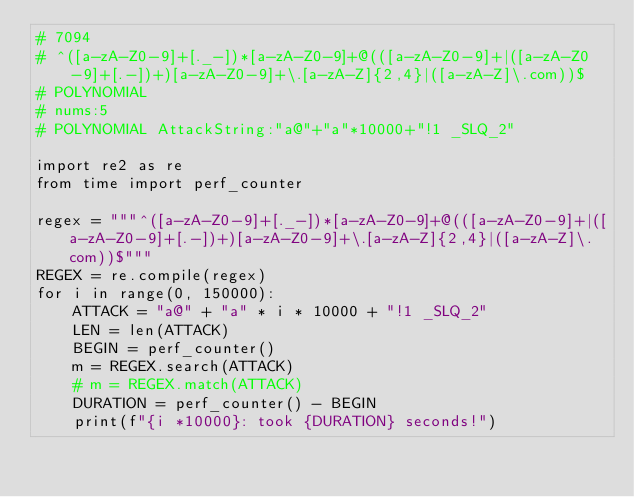<code> <loc_0><loc_0><loc_500><loc_500><_Python_># 7094
# ^([a-zA-Z0-9]+[._-])*[a-zA-Z0-9]+@(([a-zA-Z0-9]+|([a-zA-Z0-9]+[.-])+)[a-zA-Z0-9]+\.[a-zA-Z]{2,4}|([a-zA-Z]\.com))$
# POLYNOMIAL
# nums:5
# POLYNOMIAL AttackString:"a@"+"a"*10000+"!1 _SLQ_2"

import re2 as re
from time import perf_counter

regex = """^([a-zA-Z0-9]+[._-])*[a-zA-Z0-9]+@(([a-zA-Z0-9]+|([a-zA-Z0-9]+[.-])+)[a-zA-Z0-9]+\.[a-zA-Z]{2,4}|([a-zA-Z]\.com))$"""
REGEX = re.compile(regex)
for i in range(0, 150000):
    ATTACK = "a@" + "a" * i * 10000 + "!1 _SLQ_2"
    LEN = len(ATTACK)
    BEGIN = perf_counter()
    m = REGEX.search(ATTACK)
    # m = REGEX.match(ATTACK)
    DURATION = perf_counter() - BEGIN
    print(f"{i *10000}: took {DURATION} seconds!")</code> 